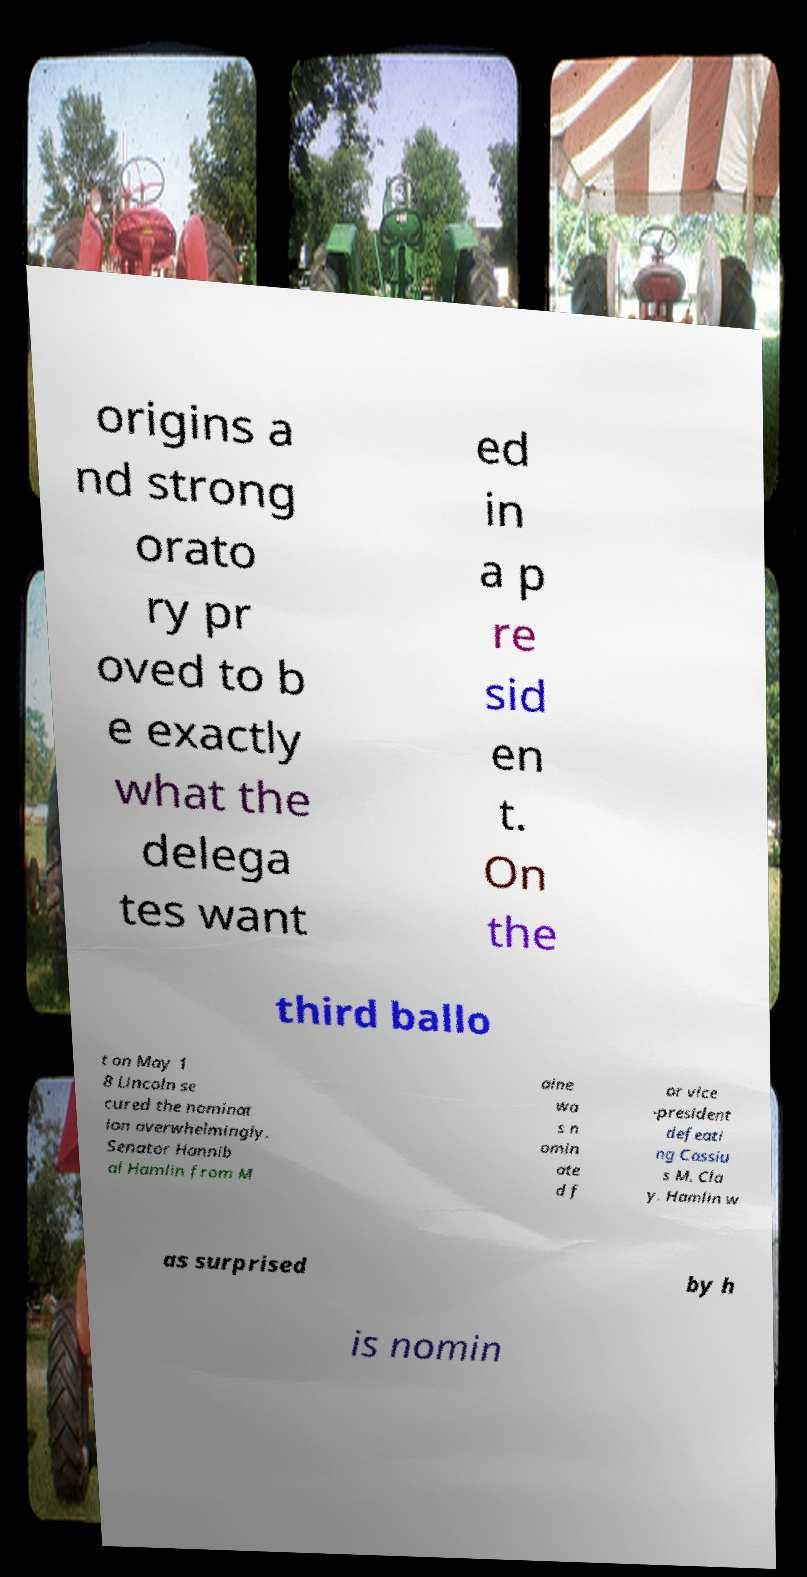I need the written content from this picture converted into text. Can you do that? origins a nd strong orato ry pr oved to b e exactly what the delega tes want ed in a p re sid en t. On the third ballo t on May 1 8 Lincoln se cured the nominat ion overwhelmingly. Senator Hannib al Hamlin from M aine wa s n omin ate d f or vice -president defeati ng Cassiu s M. Cla y. Hamlin w as surprised by h is nomin 